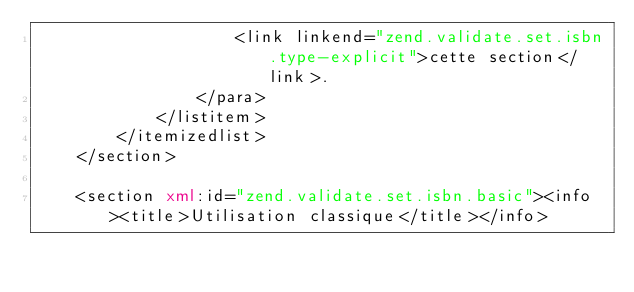Convert code to text. <code><loc_0><loc_0><loc_500><loc_500><_XML_>                    <link linkend="zend.validate.set.isbn.type-explicit">cette section</link>.
                </para>
            </listitem>
        </itemizedlist>
    </section>

    <section xml:id="zend.validate.set.isbn.basic"><info><title>Utilisation classique</title></info></code> 